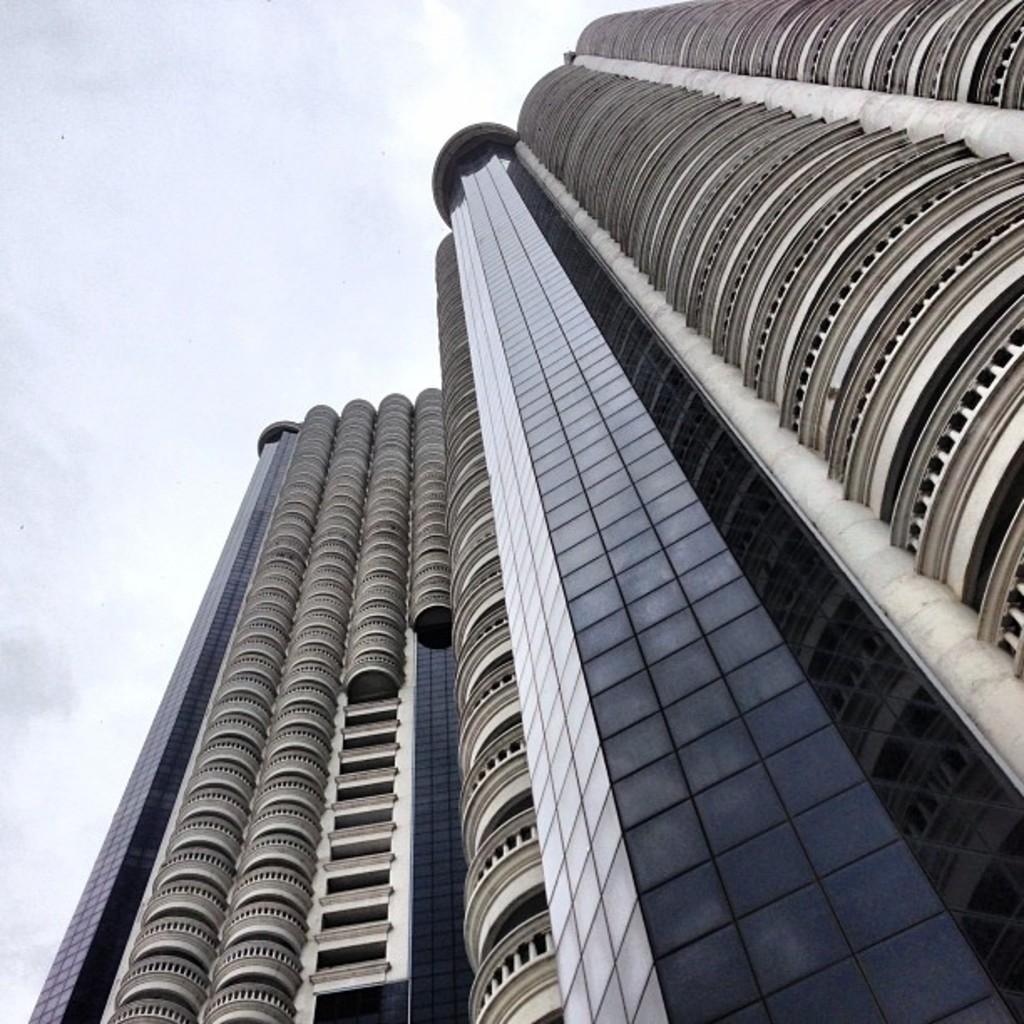Can you describe this image briefly? In this picture there is a skyscraper in the center of the image, which has many glass windows. 